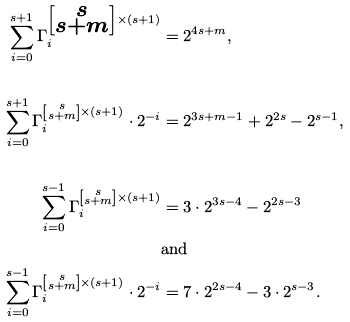Convert formula to latex. <formula><loc_0><loc_0><loc_500><loc_500>\sum _ { i = 0 } ^ { s + 1 } \Gamma _ { i } ^ { \left [ \substack { s \\ s + m } \right ] \times ( s + 1 ) } & = 2 ^ { 4 s + m } , \\ & \\ \sum _ { i = 0 } ^ { s + 1 } \Gamma _ { i } ^ { \left [ \substack { s \\ s + m } \right ] \times ( s + 1 ) } \cdot 2 ^ { - i } & = 2 ^ { 3 s + m - 1 } + 2 ^ { 2 s } - 2 ^ { s - 1 } , \\ & \\ \sum _ { i = 0 } ^ { s - 1 } \Gamma _ { i } ^ { \left [ \substack { s \\ s + m } \right ] \times ( s + 1 ) } & = 3 \cdot 2 ^ { 3 s - 4 } - 2 ^ { 2 s - 3 } \\ & \text {and} \\ \sum _ { i = 0 } ^ { s - 1 } \Gamma _ { i } ^ { \left [ \substack { s \\ s + m } \right ] \times ( s + 1 ) } \cdot 2 ^ { - i } & = 7 \cdot 2 ^ { 2 s - 4 } - 3 \cdot 2 ^ { s - 3 } .</formula> 